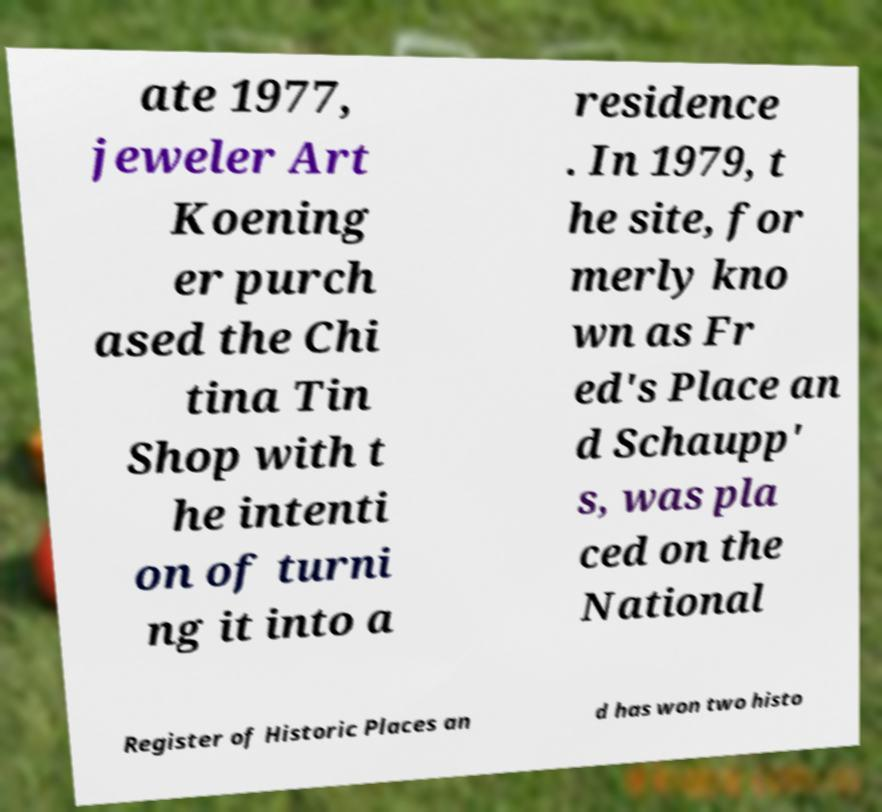I need the written content from this picture converted into text. Can you do that? ate 1977, jeweler Art Koening er purch ased the Chi tina Tin Shop with t he intenti on of turni ng it into a residence . In 1979, t he site, for merly kno wn as Fr ed's Place an d Schaupp' s, was pla ced on the National Register of Historic Places an d has won two histo 